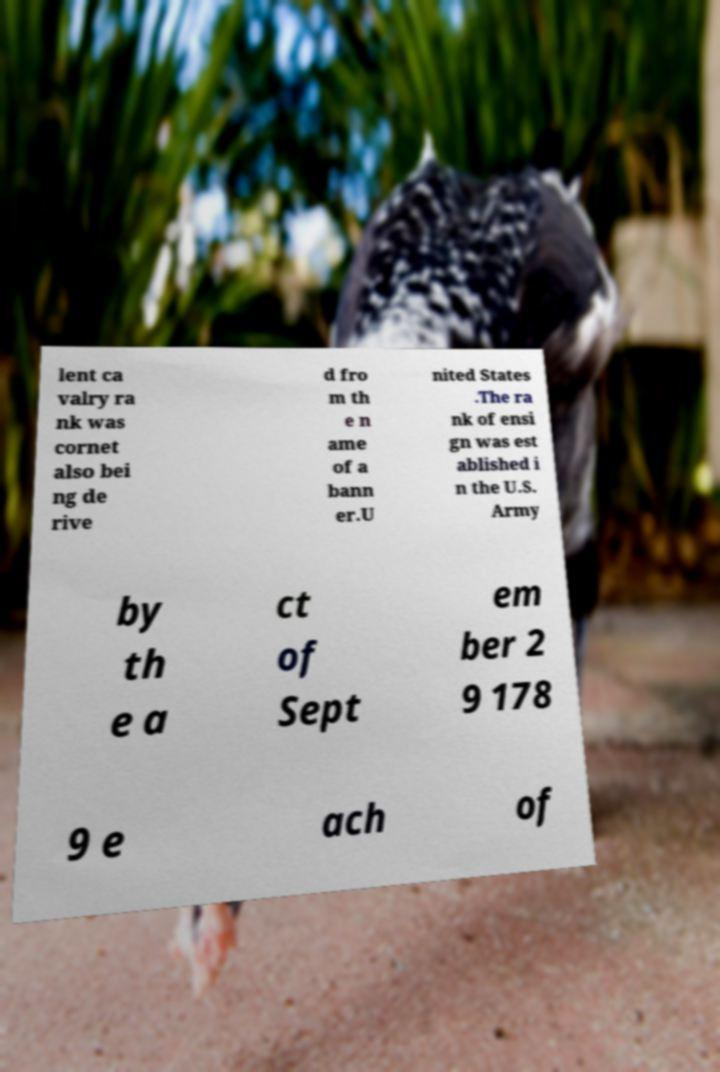Can you read and provide the text displayed in the image?This photo seems to have some interesting text. Can you extract and type it out for me? lent ca valry ra nk was cornet also bei ng de rive d fro m th e n ame of a bann er.U nited States .The ra nk of ensi gn was est ablished i n the U.S. Army by th e a ct of Sept em ber 2 9 178 9 e ach of 